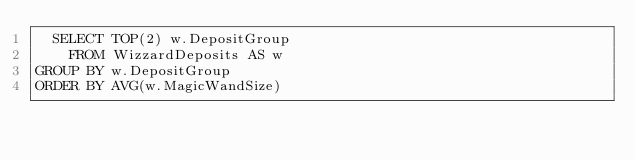Convert code to text. <code><loc_0><loc_0><loc_500><loc_500><_SQL_>  SELECT TOP(2) w.DepositGroup
    FROM WizzardDeposits AS w
GROUP BY w.DepositGroup
ORDER BY AVG(w.MagicWandSize)</code> 